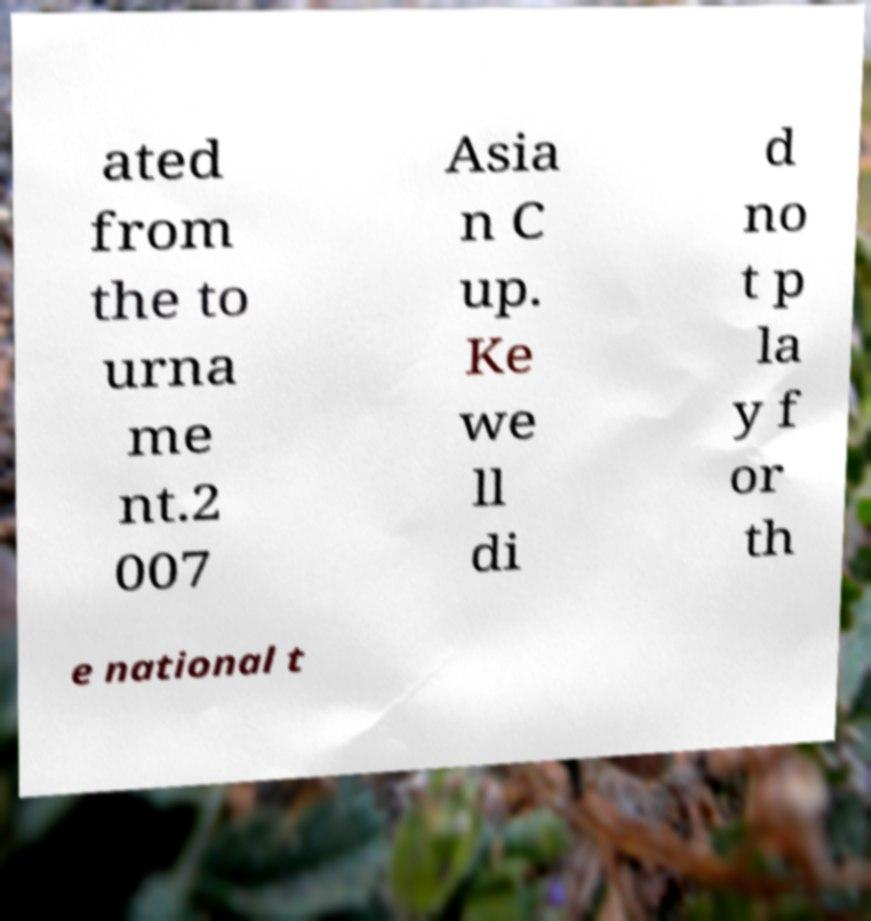There's text embedded in this image that I need extracted. Can you transcribe it verbatim? ated from the to urna me nt.2 007 Asia n C up. Ke we ll di d no t p la y f or th e national t 